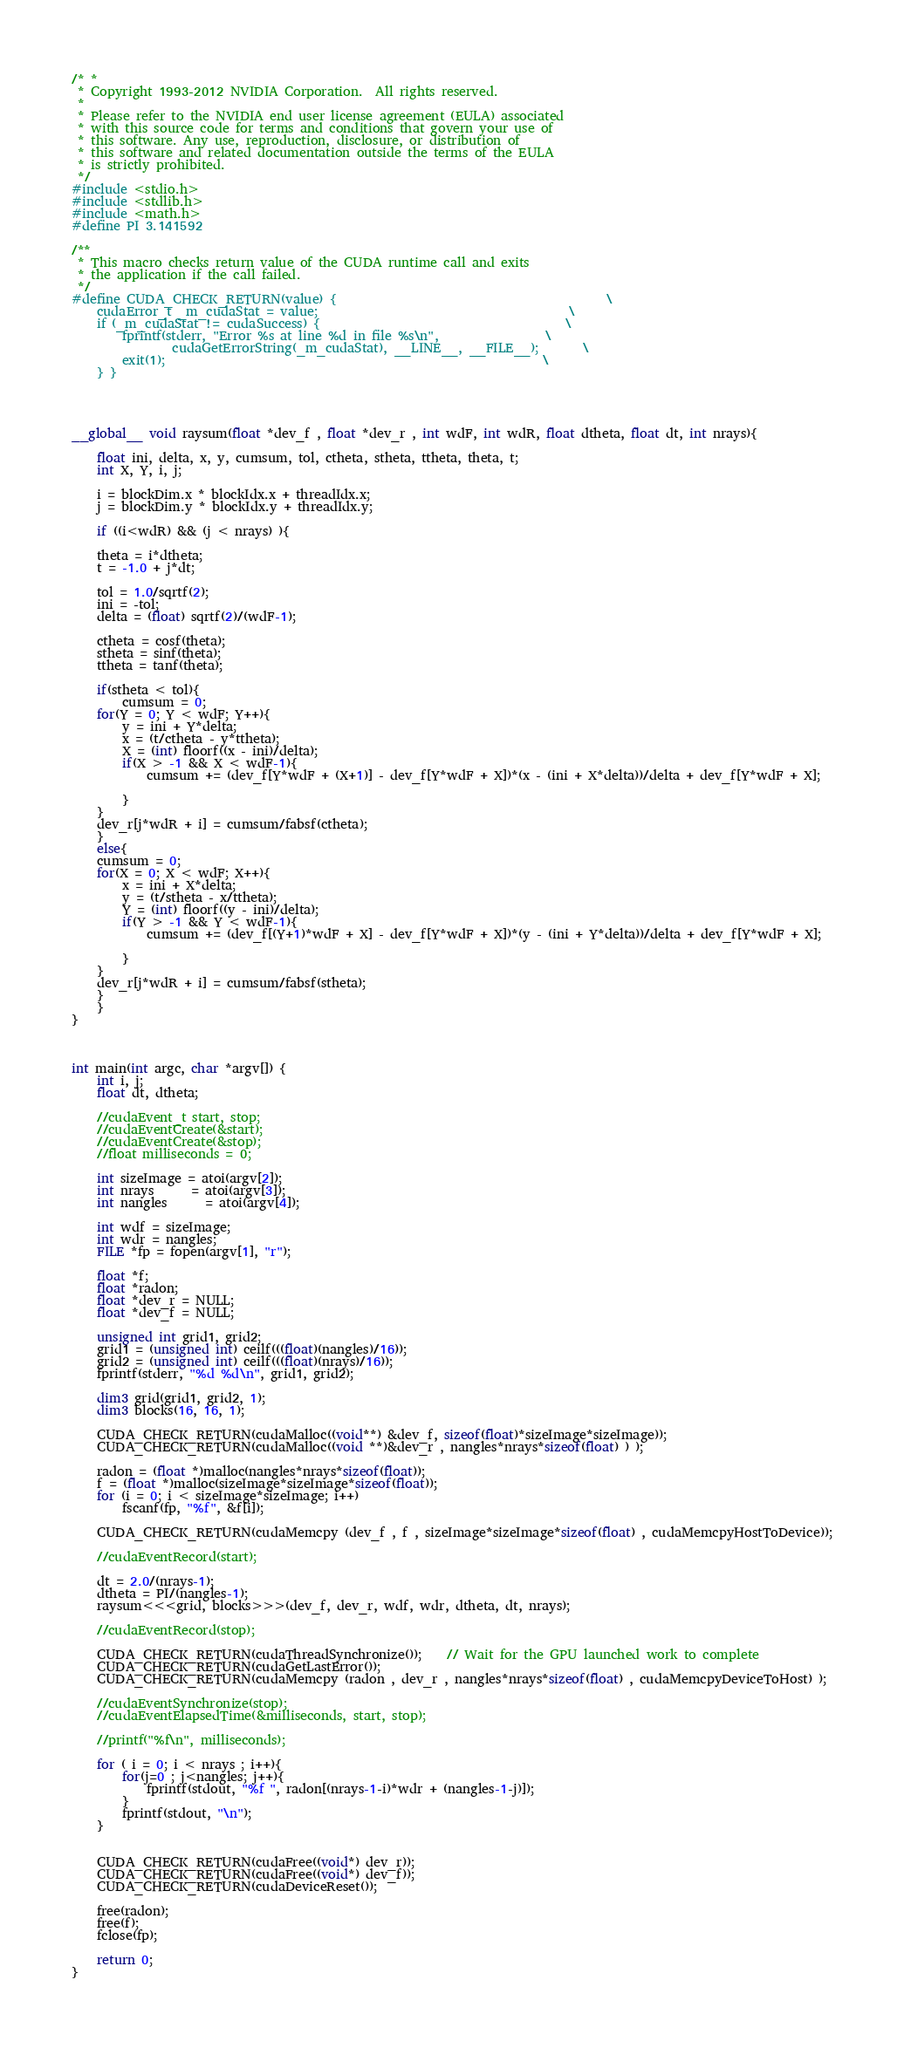<code> <loc_0><loc_0><loc_500><loc_500><_Cuda_>/* *
 * Copyright 1993-2012 NVIDIA Corporation.  All rights reserved.
 *
 * Please refer to the NVIDIA end user license agreement (EULA) associated
 * with this source code for terms and conditions that govern your use of
 * this software. Any use, reproduction, disclosure, or distribution of
 * this software and related documentation outside the terms of the EULA
 * is strictly prohibited.
 */
#include <stdio.h>
#include <stdlib.h>
#include <math.h>
#define PI 3.141592

/**
 * This macro checks return value of the CUDA runtime call and exits
 * the application if the call failed.
 */
#define CUDA_CHECK_RETURN(value) {											\
	cudaError_t _m_cudaStat = value;										\
	if (_m_cudaStat != cudaSuccess) {										\
		fprintf(stderr, "Error %s at line %d in file %s\n",					\
				cudaGetErrorString(_m_cudaStat), __LINE__, __FILE__);		\
		exit(1);															\
	} }




__global__ void raysum(float *dev_f , float *dev_r , int wdF, int wdR, float dtheta, float dt, int nrays){

	float ini, delta, x, y, cumsum, tol, ctheta, stheta, ttheta, theta, t;
	int X, Y, i, j;

	i = blockDim.x * blockIdx.x + threadIdx.x;
	j = blockDim.y * blockIdx.y + threadIdx.y;

	if ((i<wdR) && (j < nrays) ){

	theta = i*dtheta;
	t = -1.0 + j*dt;

	tol = 1.0/sqrtf(2);
	ini = -tol;
	delta = (float) sqrtf(2)/(wdF-1);

	ctheta = cosf(theta);
	stheta = sinf(theta);
	ttheta = tanf(theta);

	if(stheta < tol){
		cumsum = 0;
	for(Y = 0; Y < wdF; Y++){
		y = ini + Y*delta;
		x = (t/ctheta - y*ttheta);
		X = (int) floorf((x - ini)/delta);
	  	if(X > -1 && X < wdF-1){
			cumsum += (dev_f[Y*wdF + (X+1)] - dev_f[Y*wdF + X])*(x - (ini + X*delta))/delta + dev_f[Y*wdF + X];

		}
	}
	dev_r[j*wdR + i] = cumsum/fabsf(ctheta);
	}
	else{
	cumsum = 0;
	for(X = 0; X < wdF; X++){
		x = ini + X*delta;
		y = (t/stheta - x/ttheta);
		Y = (int) floorf((y - ini)/delta);
		if(Y > -1 && Y < wdF-1){
			cumsum += (dev_f[(Y+1)*wdF + X] - dev_f[Y*wdF + X])*(y - (ini + Y*delta))/delta + dev_f[Y*wdF + X];

		}
	}
	dev_r[j*wdR + i] = cumsum/fabsf(stheta);
	}
	}
}



int main(int argc, char *argv[]) {
	int i, j;
	float dt, dtheta;

	//cudaEvent_t start, stop;
	//cudaEventCreate(&start);
	//cudaEventCreate(&stop);
	//float milliseconds = 0;

	int sizeImage = atoi(argv[2]);
	int nrays	  = atoi(argv[3]);
	int nangles	  = atoi(argv[4]);

	int wdf = sizeImage;
	int wdr = nangles;
	FILE *fp = fopen(argv[1], "r");

	float *f;
	float *radon;
	float *dev_r = NULL;
	float *dev_f = NULL;

	unsigned int grid1, grid2;
	grid1 = (unsigned int) ceilf(((float)(nangles)/16));
	grid2 = (unsigned int) ceilf(((float)(nrays)/16));
	fprintf(stderr, "%d %d\n", grid1, grid2);

	dim3 grid(grid1, grid2, 1);
	dim3 blocks(16, 16, 1);

	CUDA_CHECK_RETURN(cudaMalloc((void**) &dev_f, sizeof(float)*sizeImage*sizeImage));
	CUDA_CHECK_RETURN(cudaMalloc((void **)&dev_r , nangles*nrays*sizeof(float) ) );

	radon = (float *)malloc(nangles*nrays*sizeof(float));
	f = (float *)malloc(sizeImage*sizeImage*sizeof(float));
	for (i = 0; i < sizeImage*sizeImage; i++)
		fscanf(fp, "%f", &f[i]);

	CUDA_CHECK_RETURN(cudaMemcpy (dev_f , f , sizeImage*sizeImage*sizeof(float) , cudaMemcpyHostToDevice));

	//cudaEventRecord(start);

	dt = 2.0/(nrays-1);
	dtheta = PI/(nangles-1);
	raysum<<<grid, blocks>>>(dev_f, dev_r, wdf, wdr, dtheta, dt, nrays);

	//cudaEventRecord(stop);

	CUDA_CHECK_RETURN(cudaThreadSynchronize());	// Wait for the GPU launched work to complete
	CUDA_CHECK_RETURN(cudaGetLastError());
	CUDA_CHECK_RETURN(cudaMemcpy (radon , dev_r , nangles*nrays*sizeof(float) , cudaMemcpyDeviceToHost) );

	//cudaEventSynchronize(stop);
	//cudaEventElapsedTime(&milliseconds, start, stop);

	//printf("%f\n", milliseconds);

	for ( i = 0; i < nrays ; i++){
		for(j=0 ; j<nangles; j++){
			fprintf(stdout, "%f ", radon[(nrays-1-i)*wdr + (nangles-1-j)]);
		}
		fprintf(stdout, "\n");
	}


	CUDA_CHECK_RETURN(cudaFree((void*) dev_r));
	CUDA_CHECK_RETURN(cudaFree((void*) dev_f));
	CUDA_CHECK_RETURN(cudaDeviceReset());

	free(radon);
	free(f);
	fclose(fp);

	return 0;
}
</code> 